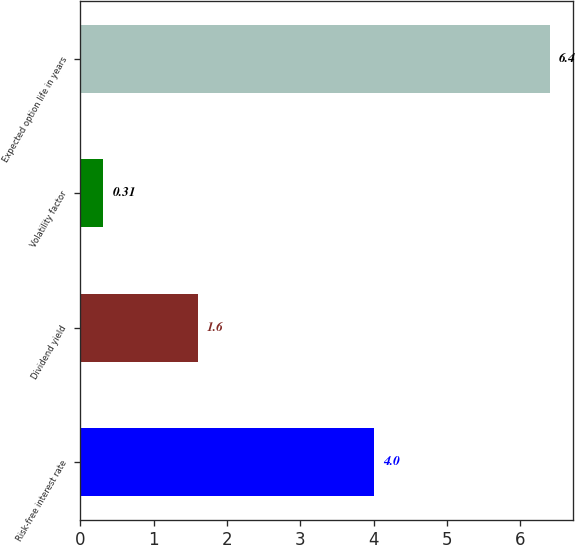Convert chart. <chart><loc_0><loc_0><loc_500><loc_500><bar_chart><fcel>Risk-free interest rate<fcel>Dividend yield<fcel>Volatility factor<fcel>Expected option life in years<nl><fcel>4<fcel>1.6<fcel>0.31<fcel>6.4<nl></chart> 